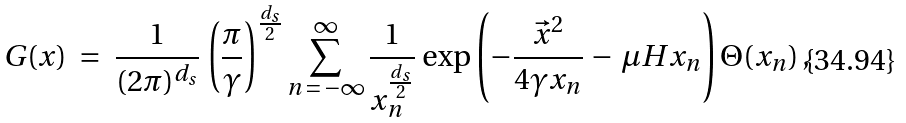<formula> <loc_0><loc_0><loc_500><loc_500>G ( x ) \ = \ \frac { 1 } { ( 2 { \pi } ) ^ { d _ { s } } } \, \left ( \frac { \pi } { \gamma } \right ) ^ { \frac { d _ { s } } { 2 } } \sum ^ { \infty } _ { n \, = \, - \infty } \frac { 1 } { x _ { n } ^ { \frac { d _ { s } } { 2 } } } \, \exp { \left ( - \frac { { \vec { x } } ^ { 2 } } { 4 \gamma x _ { n } } \, - \, \mu H x _ { n } \right ) } \, \Theta ( x _ { n } ) \, ,</formula> 